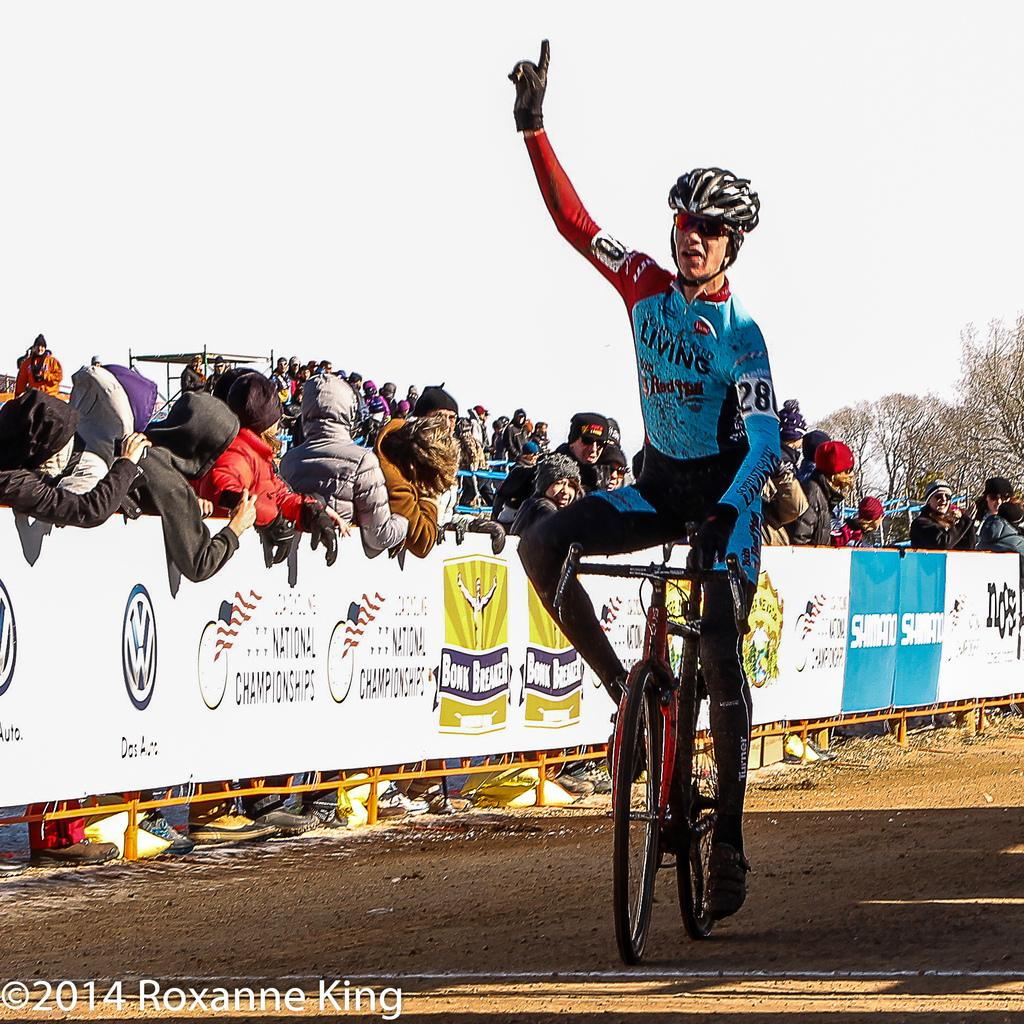What is the main subject of the image? There is a person sitting on a bicycle in the image. What can be seen on the fence in the image? There are posters on the fence in the image. What is visible in the background of the image? There are people and trees present in the background of the image. How many spiders are crawling on the branch in the image? There is no branch or spiders present in the image. What type of woman is visible in the image? There is no woman present in the image. 